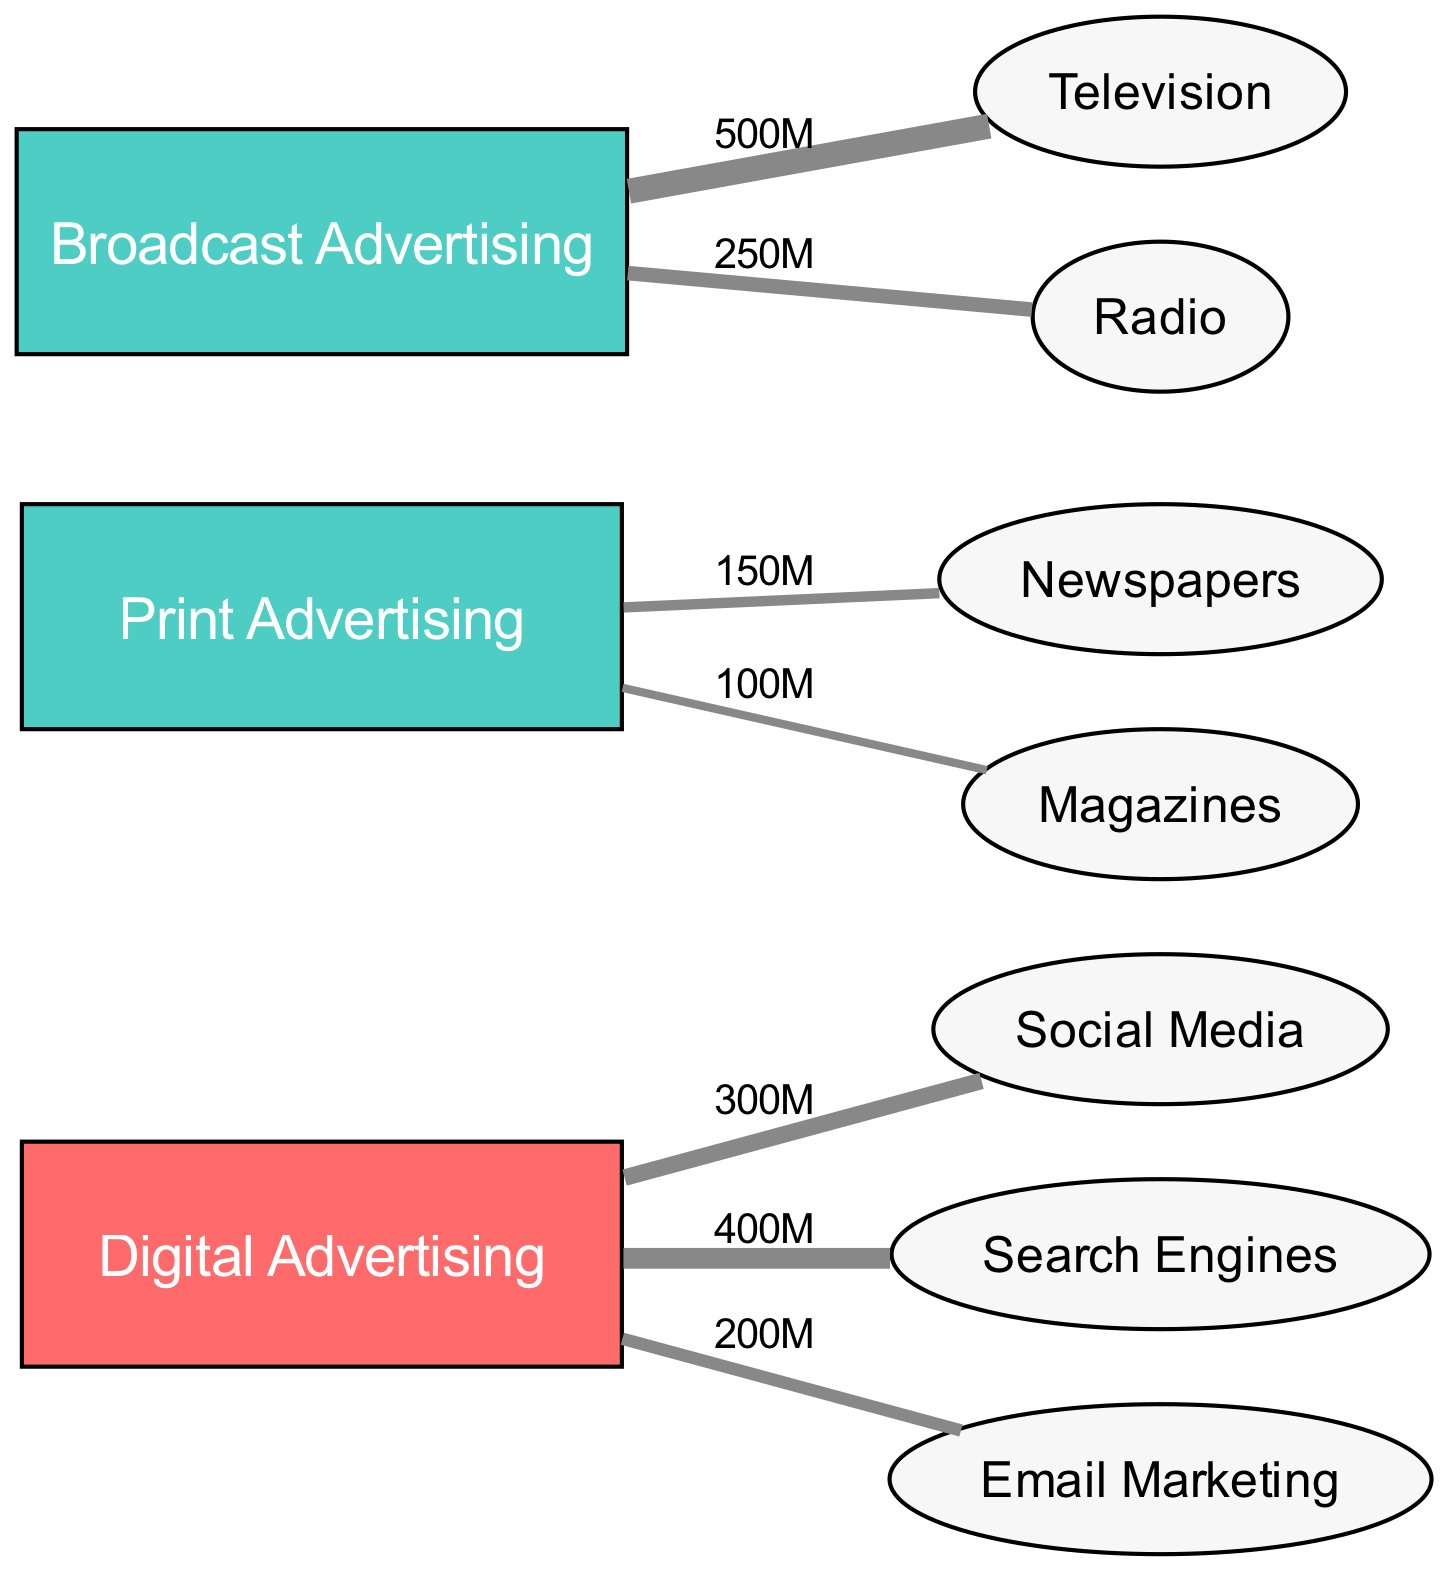What is the total revenue generated by Digital Advertising? The diagram shows that Digital Advertising has three flows: 300M to Social Media, 400M to Search Engines, and 200M to Email Marketing. Adding these amounts gives a total of 300 + 400 + 200 = 900 million
Answer: 900M Which media channel received the most revenue from Broadcast Advertising? The two flows from Broadcast Advertising are 500M to Television and 250M to Radio. Comparing these values, Television received the highest at 500 million
Answer: Television What is the total number of nodes present in the diagram? The diagram lists a total of 10 nodes, comprising 3 source nodes (Digital Advertising, Print Advertising, Broadcast Advertising) and 7 destination nodes (Social Media, Search Engines, Email Marketing, Newspapers, Magazines, Television, Radio)
Answer: 10 What is the revenue generated for Print Advertising via Newspapers? According to the diagram, Print Advertising generates 150M towards Newspapers, as represented by the flow between these two nodes
Answer: 150M Which digital channel has the lowest revenue flow? The flows from Digital Advertising show that Email Marketing receives 200M, which is the smallest compared to 300M for Social Media and 400M for Search Engines. Thus, Email Marketing has the lowest flow
Answer: Email Marketing How much greater is the revenue for Television compared to Radio from Broadcast Advertising? The revenue for Television is 500M and for Radio, it is 250M. To find the difference, subtract the Radio revenue from Television: 500 - 250 = 250 million
Answer: 250M What percentage of the total Digital Advertising revenue goes to Search Engines? The total revenue from Digital Advertising is 900M, and the amount for Search Engines is 400M. To find the percentage: (400 / 900) * 100 = approximately 44.44%. This rounds to about 44%
Answer: 44% What type of diagram is represented here? The structure and flow representation clearly show a Sankey Diagram, which is specifically used to visualize the flow of resources or revenues through various channels
Answer: Sankey Diagram What is the total amount received by all Print Advertising channels combined? Print Advertising flows to Newspapers (150M) and Magazines (100M). Adding these values gives 150 + 100 = 250 million total for Print Advertising
Answer: 250M 